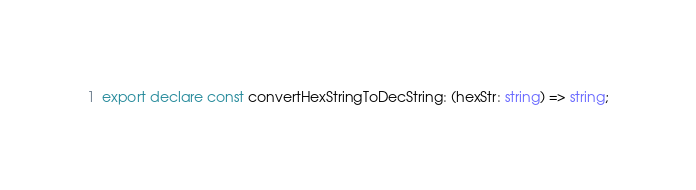Convert code to text. <code><loc_0><loc_0><loc_500><loc_500><_TypeScript_>export declare const convertHexStringToDecString: (hexStr: string) => string;
</code> 